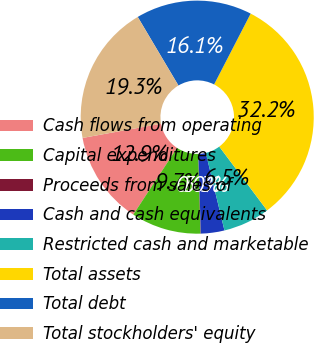Convert chart to OTSL. <chart><loc_0><loc_0><loc_500><loc_500><pie_chart><fcel>Cash flows from operating<fcel>Capital expenditures<fcel>Proceeds from sales of<fcel>Cash and cash equivalents<fcel>Restricted cash and marketable<fcel>Total assets<fcel>Total debt<fcel>Total stockholders' equity<nl><fcel>12.9%<fcel>9.69%<fcel>0.05%<fcel>3.26%<fcel>6.48%<fcel>32.18%<fcel>16.11%<fcel>19.33%<nl></chart> 